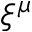Convert formula to latex. <formula><loc_0><loc_0><loc_500><loc_500>\xi ^ { \mu }</formula> 